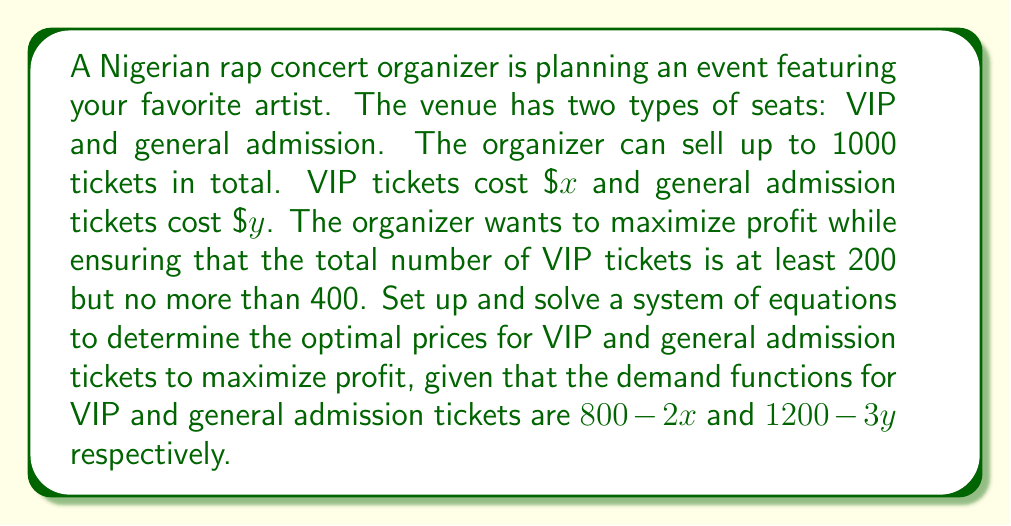Help me with this question. Let's approach this step-by-step:

1) Let v be the number of VIP tickets and g be the number of general admission tickets.

2) From the given information:
   $v + g \leq 1000$ (total tickets constraint)
   $200 \leq v \leq 400$ (VIP ticket constraint)

3) The demand functions give us:
   $v = 800 - 2x$
   $g = 1200 - 3y$

4) The profit function P is:
   $P = xv + yg = x(800-2x) + y(1200-3y)$

5) To maximize profit, we need to find the partial derivatives with respect to x and y and set them to zero:

   $\frac{\partial P}{\partial x} = 800 - 4x = 0$
   $\frac{\partial P}{\partial y} = 1200 - 6y = 0$

6) Solving these equations:
   $x = 200$
   $y = 200$

7) Now, let's check if these values satisfy our constraints:
   $v = 800 - 2(200) = 400$
   $g = 1200 - 3(200) = 600$

   $v + g = 400 + 600 = 1000$ (satisfies total ticket constraint)
   $400$ is within the VIP ticket constraint of 200 to 400

8) Therefore, the optimal prices are:
   VIP tickets: $200
   General admission tickets: $200

9) The maximum profit is:
   $P = 200(400) + 200(600) = 80,000 + 120,000 = 200,000$
Answer: VIP: $200, General: $200, Max Profit: $200,000 